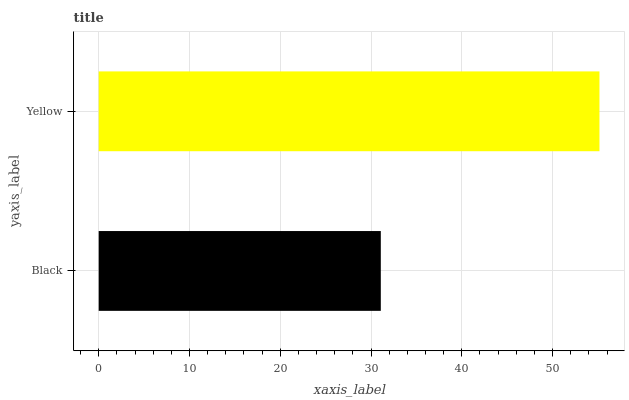Is Black the minimum?
Answer yes or no. Yes. Is Yellow the maximum?
Answer yes or no. Yes. Is Yellow the minimum?
Answer yes or no. No. Is Yellow greater than Black?
Answer yes or no. Yes. Is Black less than Yellow?
Answer yes or no. Yes. Is Black greater than Yellow?
Answer yes or no. No. Is Yellow less than Black?
Answer yes or no. No. Is Yellow the high median?
Answer yes or no. Yes. Is Black the low median?
Answer yes or no. Yes. Is Black the high median?
Answer yes or no. No. Is Yellow the low median?
Answer yes or no. No. 